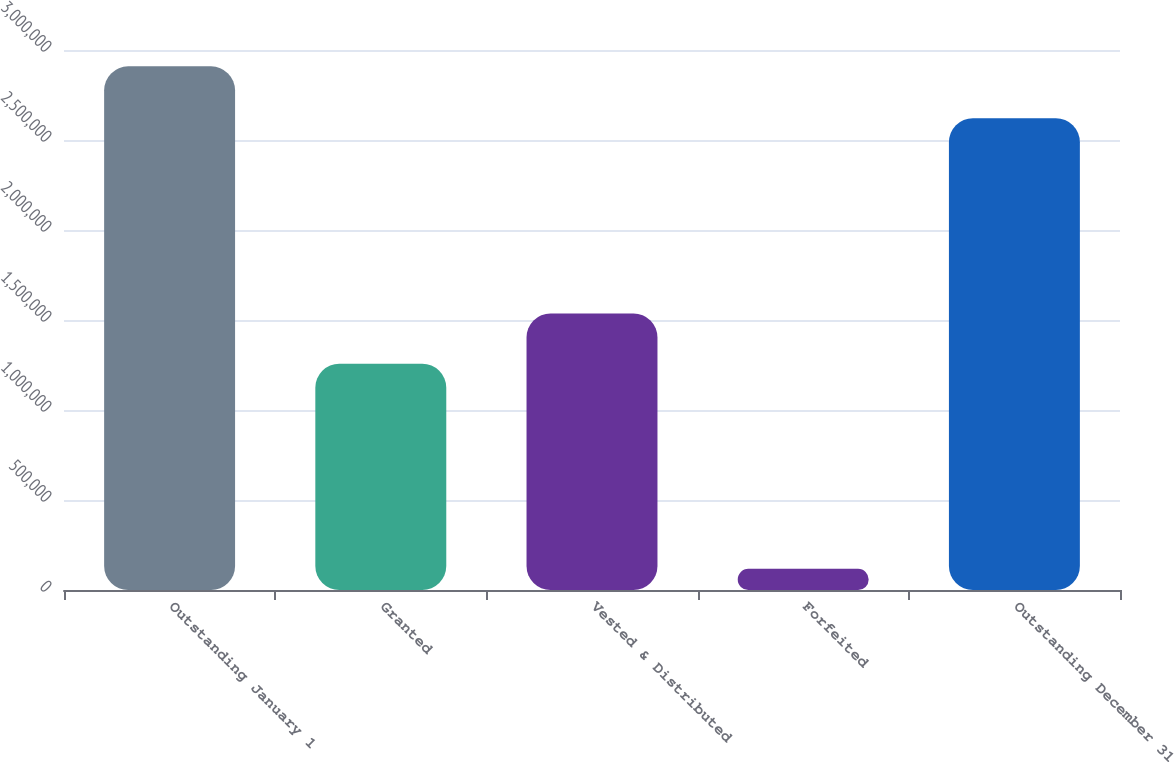Convert chart. <chart><loc_0><loc_0><loc_500><loc_500><bar_chart><fcel>Outstanding January 1<fcel>Granted<fcel>Vested & Distributed<fcel>Forfeited<fcel>Outstanding December 31<nl><fcel>2.90903e+06<fcel>1.25682e+06<fcel>1.53597e+06<fcel>117481<fcel>2.62151e+06<nl></chart> 